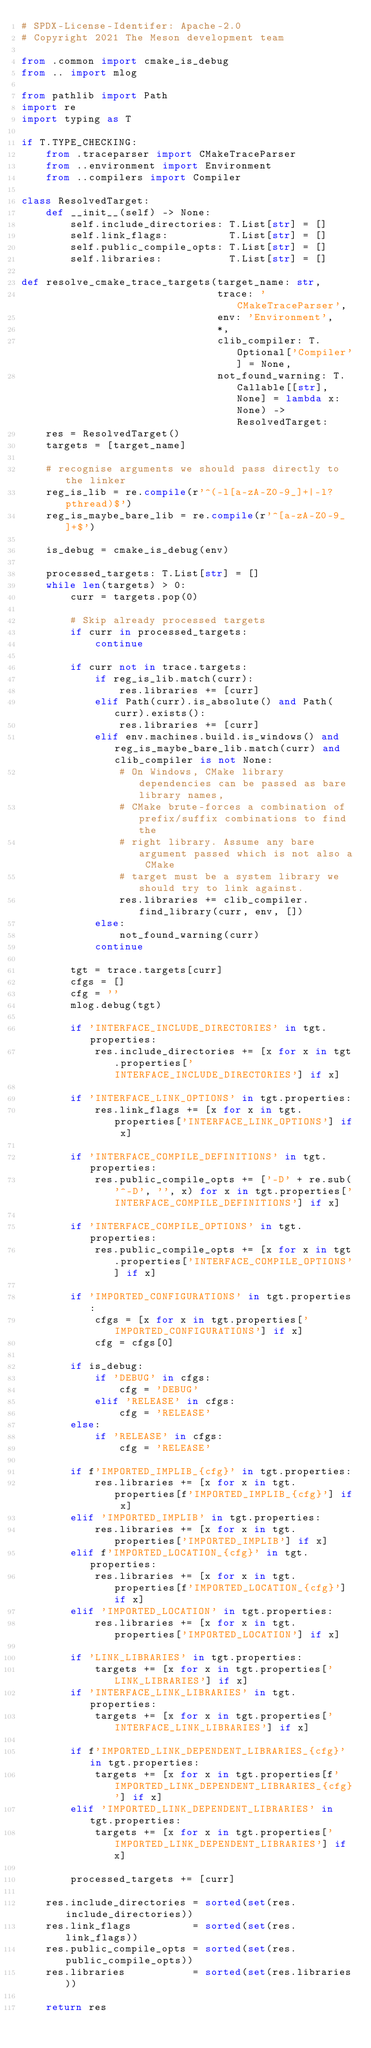Convert code to text. <code><loc_0><loc_0><loc_500><loc_500><_Python_># SPDX-License-Identifer: Apache-2.0
# Copyright 2021 The Meson development team

from .common import cmake_is_debug
from .. import mlog

from pathlib import Path
import re
import typing as T

if T.TYPE_CHECKING:
    from .traceparser import CMakeTraceParser
    from ..environment import Environment
    from ..compilers import Compiler

class ResolvedTarget:
    def __init__(self) -> None:
        self.include_directories: T.List[str] = []
        self.link_flags:          T.List[str] = []
        self.public_compile_opts: T.List[str] = []
        self.libraries:           T.List[str] = []

def resolve_cmake_trace_targets(target_name: str,
                                trace: 'CMakeTraceParser',
                                env: 'Environment',
                                *,
                                clib_compiler: T.Optional['Compiler'] = None,
                                not_found_warning: T.Callable[[str], None] = lambda x: None) -> ResolvedTarget:
    res = ResolvedTarget()
    targets = [target_name]

    # recognise arguments we should pass directly to the linker
    reg_is_lib = re.compile(r'^(-l[a-zA-Z0-9_]+|-l?pthread)$')
    reg_is_maybe_bare_lib = re.compile(r'^[a-zA-Z0-9_]+$')

    is_debug = cmake_is_debug(env)

    processed_targets: T.List[str] = []
    while len(targets) > 0:
        curr = targets.pop(0)

        # Skip already processed targets
        if curr in processed_targets:
            continue

        if curr not in trace.targets:
            if reg_is_lib.match(curr):
                res.libraries += [curr]
            elif Path(curr).is_absolute() and Path(curr).exists():
                res.libraries += [curr]
            elif env.machines.build.is_windows() and reg_is_maybe_bare_lib.match(curr) and clib_compiler is not None:
                # On Windows, CMake library dependencies can be passed as bare library names,
                # CMake brute-forces a combination of prefix/suffix combinations to find the
                # right library. Assume any bare argument passed which is not also a CMake
                # target must be a system library we should try to link against.
                res.libraries += clib_compiler.find_library(curr, env, [])
            else:
                not_found_warning(curr)
            continue

        tgt = trace.targets[curr]
        cfgs = []
        cfg = ''
        mlog.debug(tgt)

        if 'INTERFACE_INCLUDE_DIRECTORIES' in tgt.properties:
            res.include_directories += [x for x in tgt.properties['INTERFACE_INCLUDE_DIRECTORIES'] if x]

        if 'INTERFACE_LINK_OPTIONS' in tgt.properties:
            res.link_flags += [x for x in tgt.properties['INTERFACE_LINK_OPTIONS'] if x]

        if 'INTERFACE_COMPILE_DEFINITIONS' in tgt.properties:
            res.public_compile_opts += ['-D' + re.sub('^-D', '', x) for x in tgt.properties['INTERFACE_COMPILE_DEFINITIONS'] if x]

        if 'INTERFACE_COMPILE_OPTIONS' in tgt.properties:
            res.public_compile_opts += [x for x in tgt.properties['INTERFACE_COMPILE_OPTIONS'] if x]

        if 'IMPORTED_CONFIGURATIONS' in tgt.properties:
            cfgs = [x for x in tgt.properties['IMPORTED_CONFIGURATIONS'] if x]
            cfg = cfgs[0]

        if is_debug:
            if 'DEBUG' in cfgs:
                cfg = 'DEBUG'
            elif 'RELEASE' in cfgs:
                cfg = 'RELEASE'
        else:
            if 'RELEASE' in cfgs:
                cfg = 'RELEASE'

        if f'IMPORTED_IMPLIB_{cfg}' in tgt.properties:
            res.libraries += [x for x in tgt.properties[f'IMPORTED_IMPLIB_{cfg}'] if x]
        elif 'IMPORTED_IMPLIB' in tgt.properties:
            res.libraries += [x for x in tgt.properties['IMPORTED_IMPLIB'] if x]
        elif f'IMPORTED_LOCATION_{cfg}' in tgt.properties:
            res.libraries += [x for x in tgt.properties[f'IMPORTED_LOCATION_{cfg}'] if x]
        elif 'IMPORTED_LOCATION' in tgt.properties:
            res.libraries += [x for x in tgt.properties['IMPORTED_LOCATION'] if x]

        if 'LINK_LIBRARIES' in tgt.properties:
            targets += [x for x in tgt.properties['LINK_LIBRARIES'] if x]
        if 'INTERFACE_LINK_LIBRARIES' in tgt.properties:
            targets += [x for x in tgt.properties['INTERFACE_LINK_LIBRARIES'] if x]

        if f'IMPORTED_LINK_DEPENDENT_LIBRARIES_{cfg}' in tgt.properties:
            targets += [x for x in tgt.properties[f'IMPORTED_LINK_DEPENDENT_LIBRARIES_{cfg}'] if x]
        elif 'IMPORTED_LINK_DEPENDENT_LIBRARIES' in tgt.properties:
            targets += [x for x in tgt.properties['IMPORTED_LINK_DEPENDENT_LIBRARIES'] if x]

        processed_targets += [curr]

    res.include_directories = sorted(set(res.include_directories))
    res.link_flags          = sorted(set(res.link_flags))
    res.public_compile_opts = sorted(set(res.public_compile_opts))
    res.libraries           = sorted(set(res.libraries))

    return res
</code> 